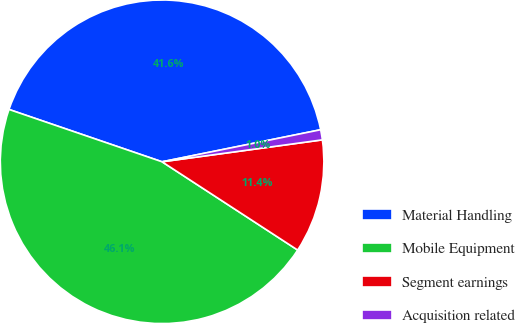Convert chart. <chart><loc_0><loc_0><loc_500><loc_500><pie_chart><fcel>Material Handling<fcel>Mobile Equipment<fcel>Segment earnings<fcel>Acquisition related<nl><fcel>41.58%<fcel>46.06%<fcel>11.35%<fcel>1.01%<nl></chart> 